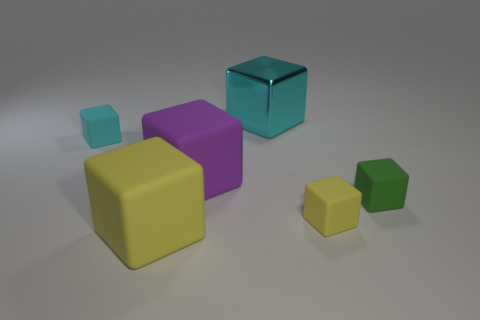Is there anything else that is the same material as the big cyan block?
Ensure brevity in your answer.  No. The large cube that is on the right side of the purple matte thing in front of the cyan thing in front of the metal object is made of what material?
Provide a short and direct response. Metal. What is the size of the purple block that is made of the same material as the tiny cyan object?
Provide a succinct answer. Large. There is a rubber thing in front of the yellow cube on the right side of the large metallic cube; what color is it?
Ensure brevity in your answer.  Yellow. What number of big purple cubes have the same material as the tiny cyan cube?
Give a very brief answer. 1. How many metallic objects are large cyan cubes or big cyan cylinders?
Offer a very short reply. 1. What is the material of the cyan cube that is the same size as the green cube?
Make the answer very short. Rubber. Are there any large blue cubes made of the same material as the small green block?
Your response must be concise. No. There is a cyan thing right of the large rubber cube behind the yellow object right of the big purple object; what shape is it?
Provide a short and direct response. Cube. Do the purple rubber thing and the rubber cube to the right of the tiny yellow block have the same size?
Give a very brief answer. No. 